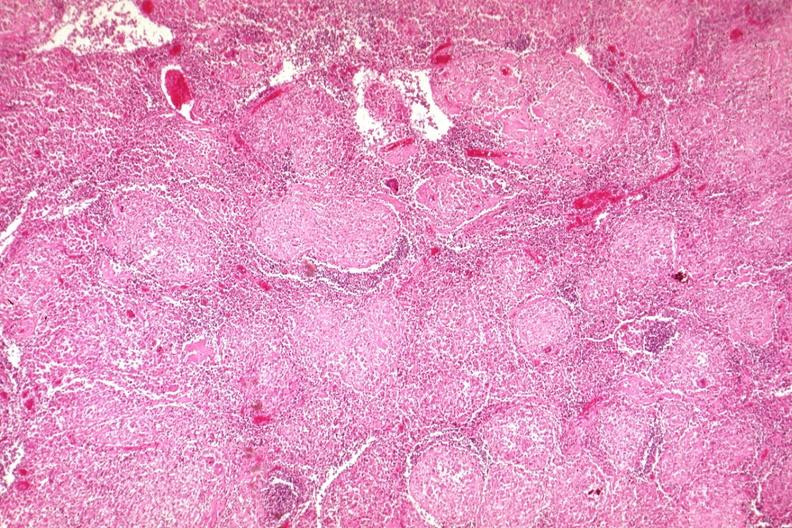does fixed tissue show typical granulomas?
Answer the question using a single word or phrase. No 